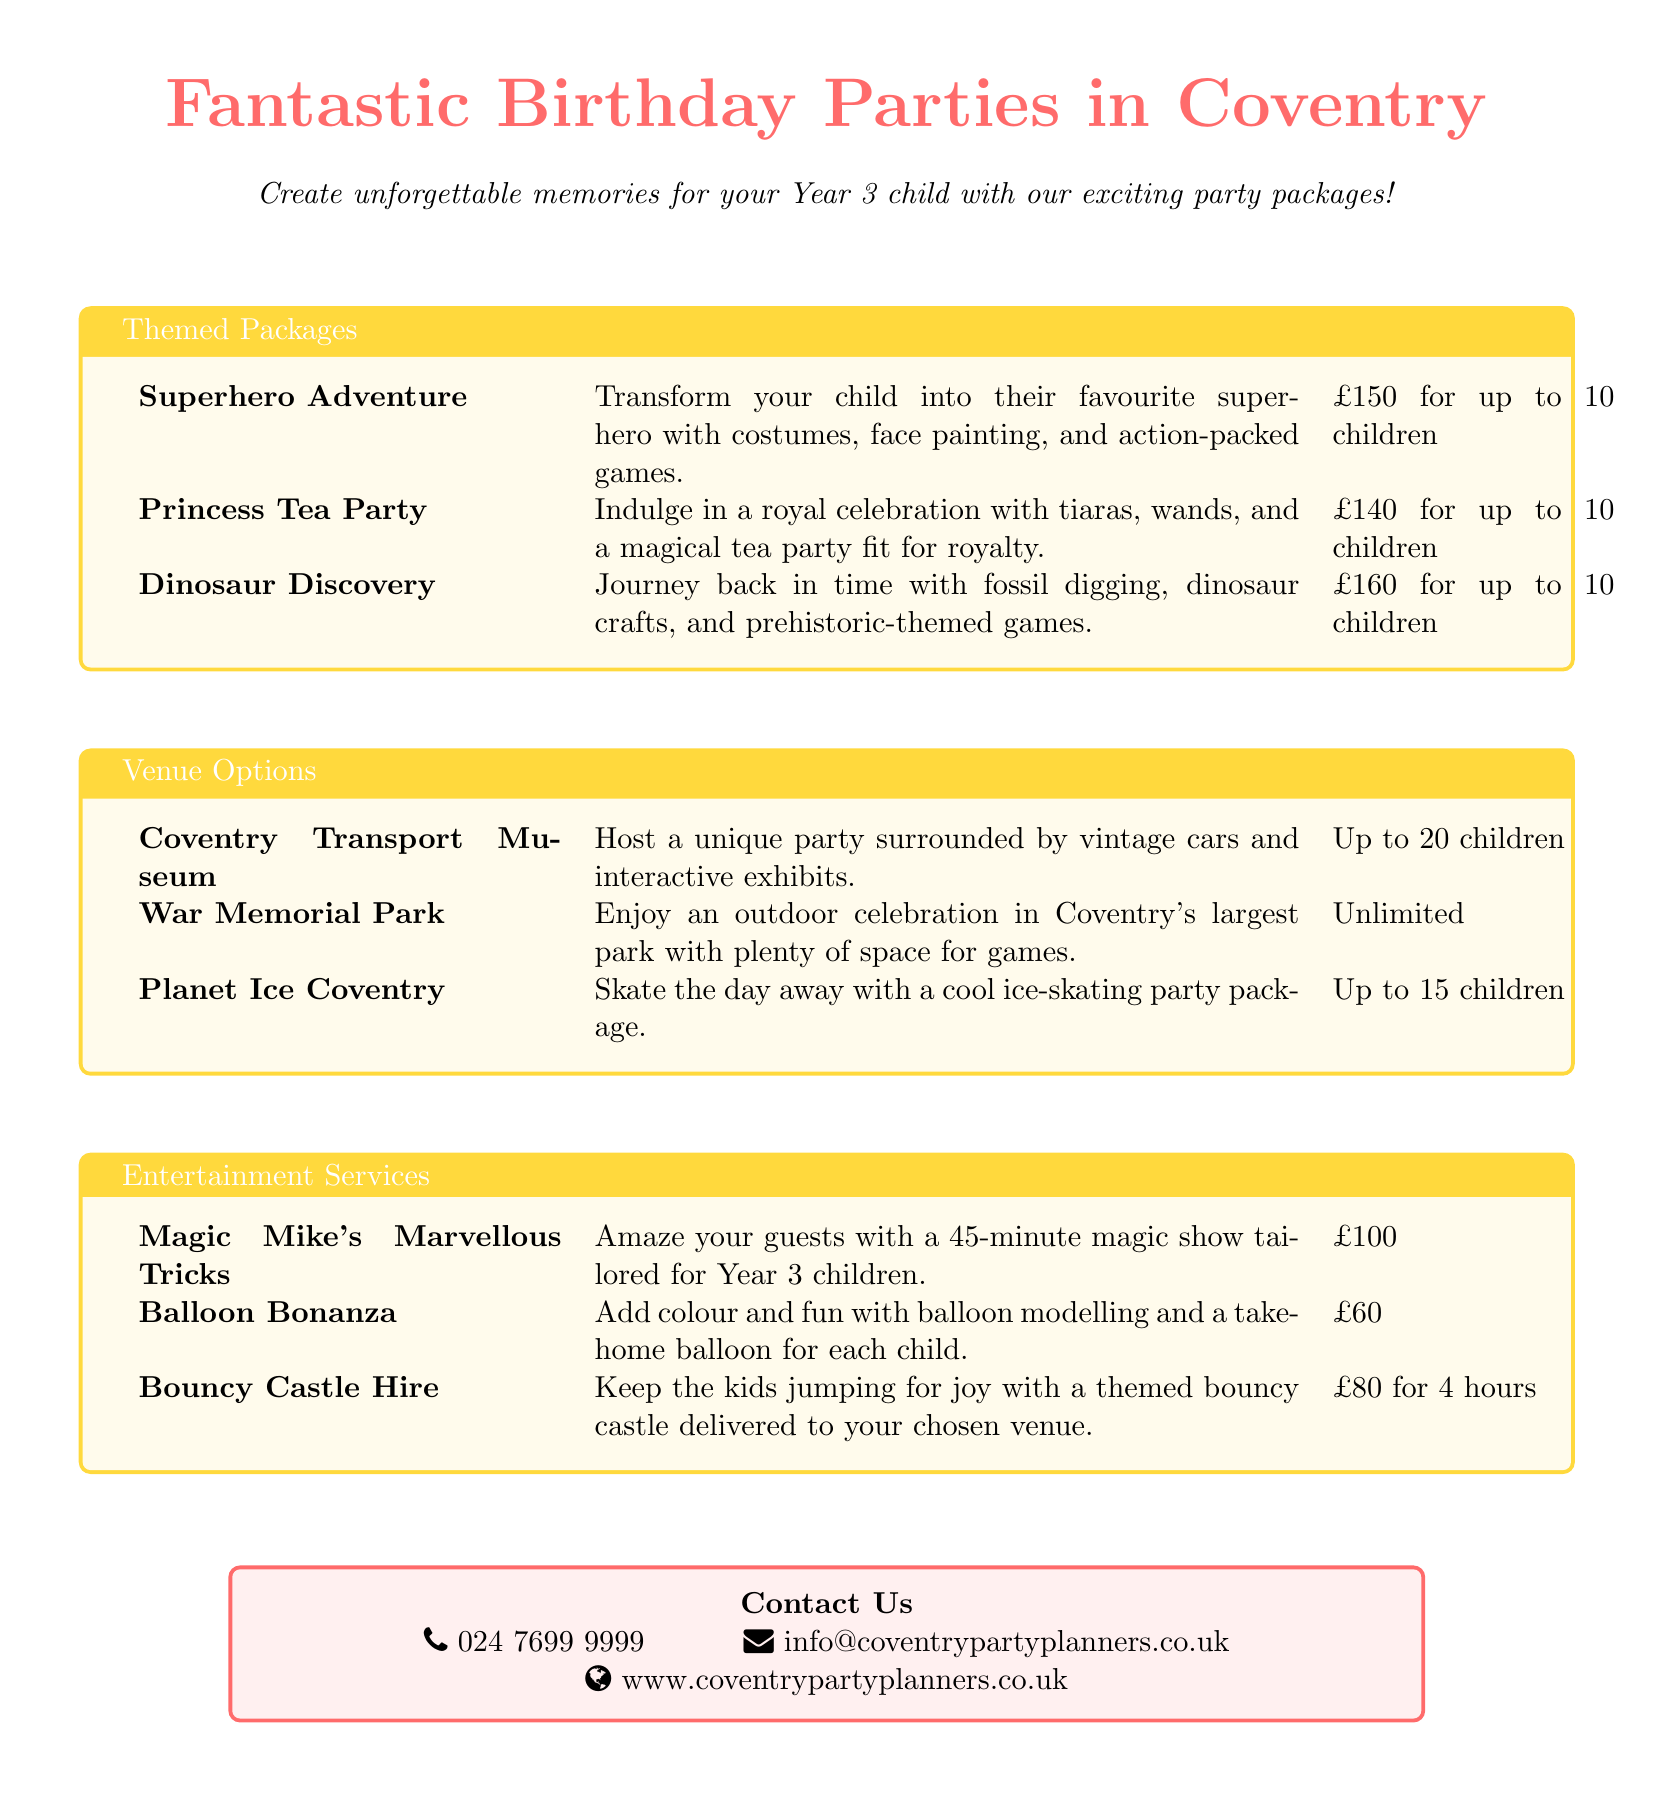What is the price for the Superhero Adventure package? The price is listed in the themed packages section of the document as £150 for up to 10 children.
Answer: £150 How many children can be accommodated at the Warwick Park venue? The venue options section indicates that the War Memorial Park can accommodate unlimited children.
Answer: Unlimited What type of show does Magic Mike offer? Magic Mike's service in the entertainment section involves a magic show tailored for Year 3 children.
Answer: Magic show What is included in the Princess Tea Party package? The Princess Tea Party package includes tiaras, wands, and a magical tea party.
Answer: Tiaras, wands, magical tea party What is the hourly rate for Bouncy Castle Hire? The Bouncy Castle Hire price is specified as £80 for 4 hours in the entertainment services section.
Answer: £80 for 4 hours How many children can the Planet Ice Coventry accommodate? The venue options indicate that Planet Ice Coventry can host up to 15 children.
Answer: Up to 15 children What is the total price for the Dinosaur Discovery package? The Dinosaur Discovery package costs £160 for up to 10 children as per the themed packages section.
Answer: £160 What entertainment service costs £60? The entertainment section lists Balloon Bonanza at a cost of £60.
Answer: £60 